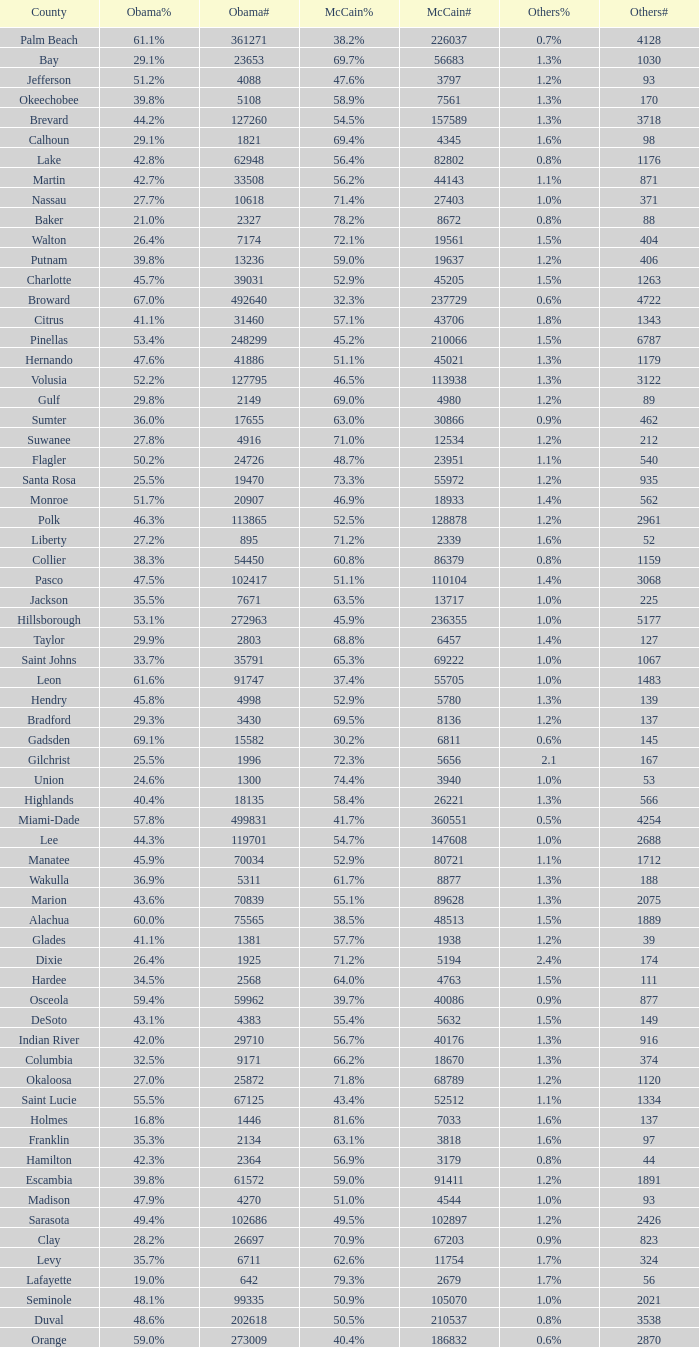How many numbers were recorded under McCain when Obama had 27.2% voters? 1.0. 